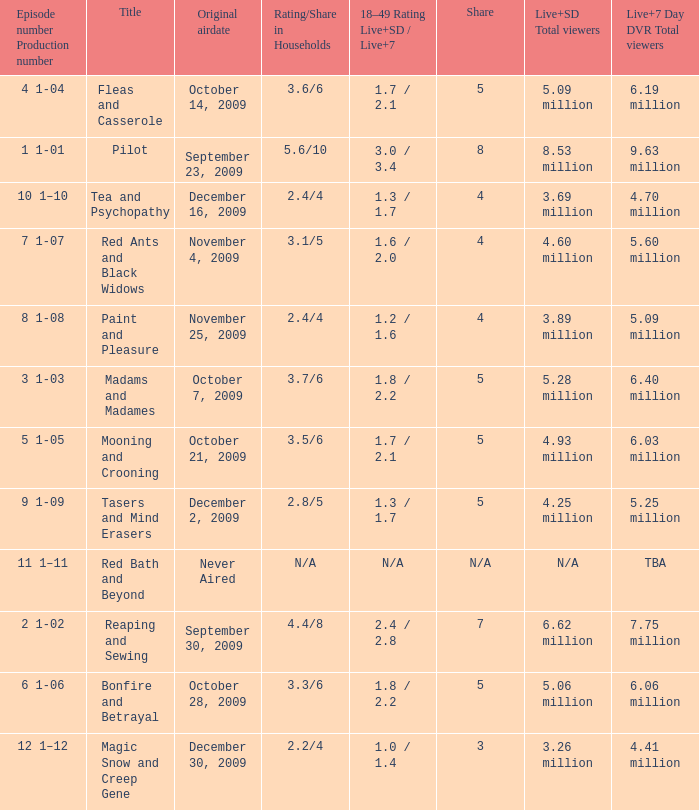Help me parse the entirety of this table. {'header': ['Episode number Production number', 'Title', 'Original airdate', 'Rating/Share in Households', '18–49 Rating Live+SD / Live+7', 'Share', 'Live+SD Total viewers', 'Live+7 Day DVR Total viewers'], 'rows': [['4 1-04', 'Fleas and Casserole', 'October 14, 2009', '3.6/6', '1.7 / 2.1', '5', '5.09 million', '6.19 million'], ['1 1-01', 'Pilot', 'September 23, 2009', '5.6/10', '3.0 / 3.4', '8', '8.53 million', '9.63 million'], ['10 1–10', 'Tea and Psychopathy', 'December 16, 2009', '2.4/4', '1.3 / 1.7', '4', '3.69 million', '4.70 million'], ['7 1-07', 'Red Ants and Black Widows', 'November 4, 2009', '3.1/5', '1.6 / 2.0', '4', '4.60 million', '5.60 million'], ['8 1-08', 'Paint and Pleasure', 'November 25, 2009', '2.4/4', '1.2 / 1.6', '4', '3.89 million', '5.09 million'], ['3 1-03', 'Madams and Madames', 'October 7, 2009', '3.7/6', '1.8 / 2.2', '5', '5.28 million', '6.40 million'], ['5 1-05', 'Mooning and Crooning', 'October 21, 2009', '3.5/6', '1.7 / 2.1', '5', '4.93 million', '6.03 million'], ['9 1-09', 'Tasers and Mind Erasers', 'December 2, 2009', '2.8/5', '1.3 / 1.7', '5', '4.25 million', '5.25 million'], ['11 1–11', 'Red Bath and Beyond', 'Never Aired', 'N/A', 'N/A', 'N/A', 'N/A', 'TBA'], ['2 1-02', 'Reaping and Sewing', 'September 30, 2009', '4.4/8', '2.4 / 2.8', '7', '6.62 million', '7.75 million'], ['6 1-06', 'Bonfire and Betrayal', 'October 28, 2009', '3.3/6', '1.8 / 2.2', '5', '5.06 million', '6.06 million'], ['12 1–12', 'Magic Snow and Creep Gene', 'December 30, 2009', '2.2/4', '1.0 / 1.4', '3', '3.26 million', '4.41 million']]} When did the episode that had 3.69 million total viewers (Live and SD types combined) first air? December 16, 2009. 